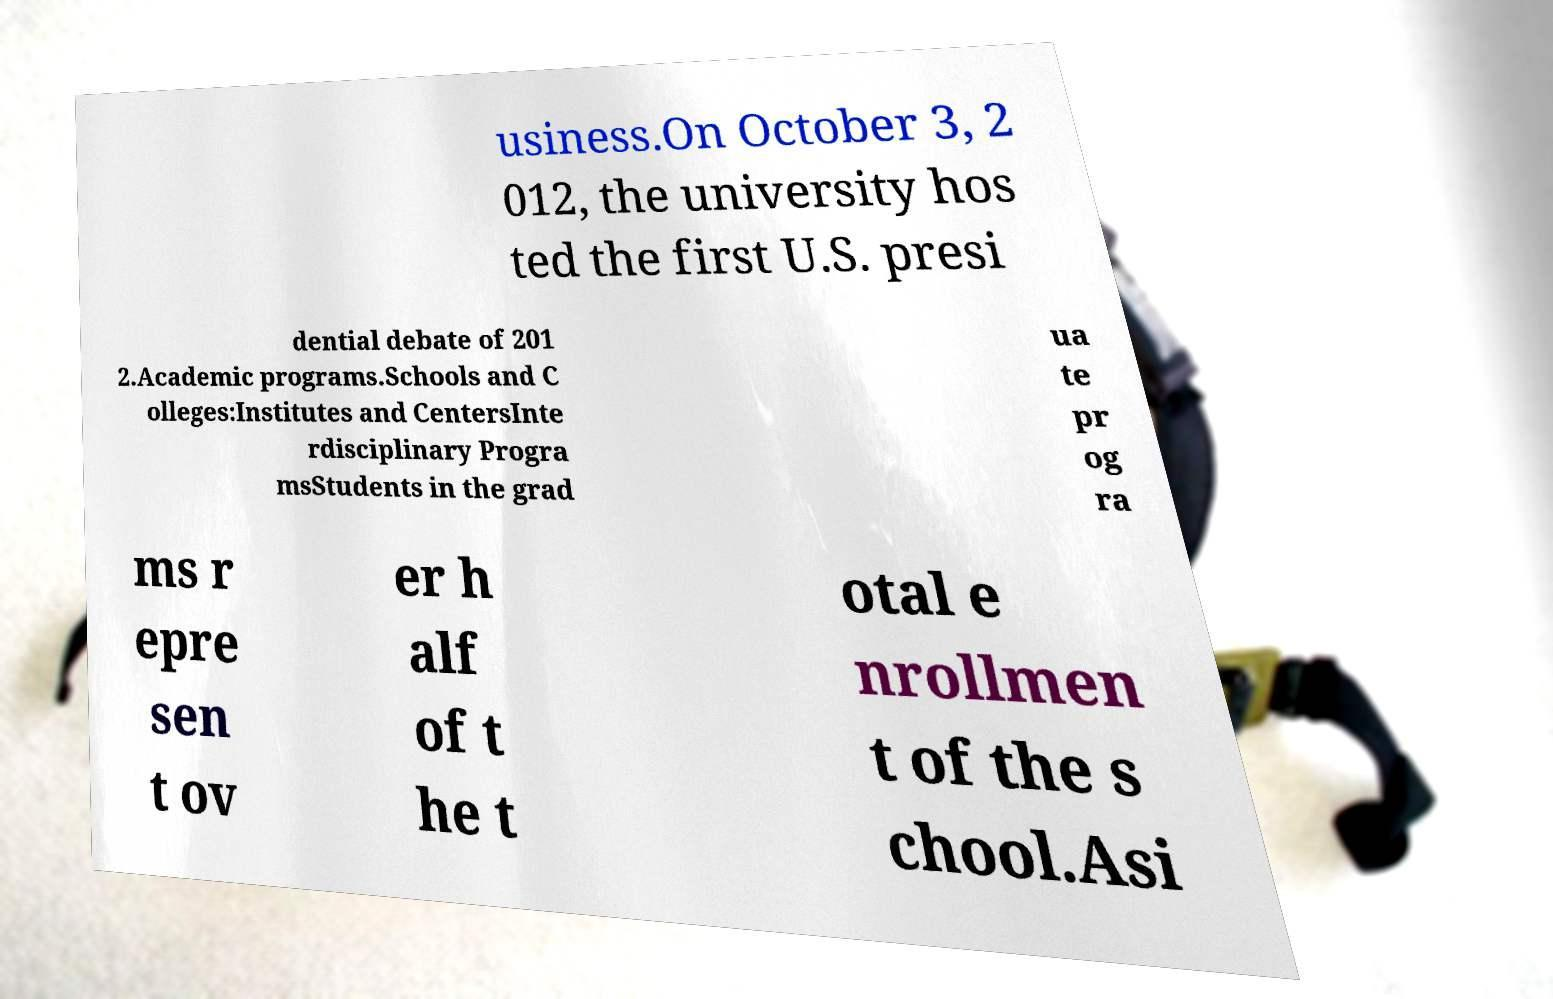Can you read and provide the text displayed in the image?This photo seems to have some interesting text. Can you extract and type it out for me? usiness.On October 3, 2 012, the university hos ted the first U.S. presi dential debate of 201 2.Academic programs.Schools and C olleges:Institutes and CentersInte rdisciplinary Progra msStudents in the grad ua te pr og ra ms r epre sen t ov er h alf of t he t otal e nrollmen t of the s chool.Asi 